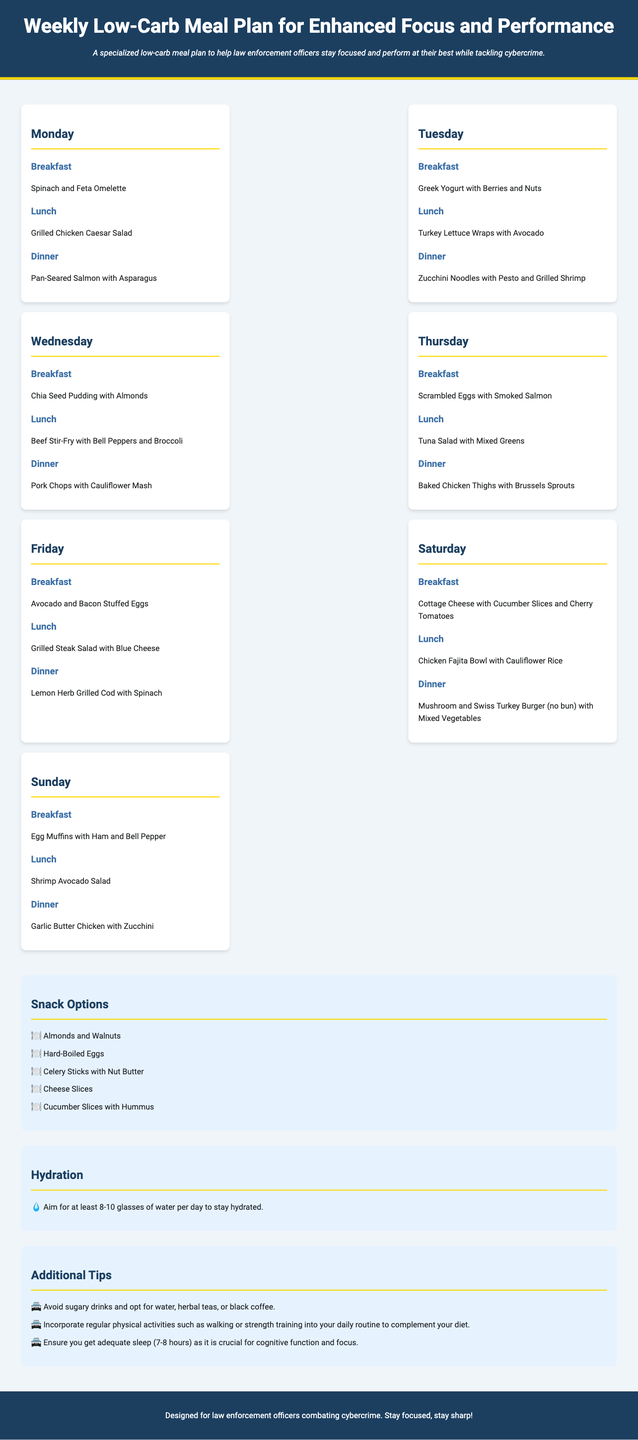What is the title of the meal plan? The title of the meal plan is provided in the header of the document.
Answer: Weekly Low-Carb Meal Plan for Enhanced Focus and Performance How many meals are outlined for each day? Each day contains three meals: breakfast, lunch, and dinner, as detailed in the meal plan section.
Answer: 3 What is the breakfast option for Wednesday? The breakfast option for Wednesday is listed in the meal details for that day.
Answer: Chia Seed Pudding with Almonds Which snack includes nut butter? The options listed in the snack section indicate which ones contain nut butter.
Answer: Celery Sticks with Nut Butter What is recommended for hydration? The hydration section of the document specifies what should be consumed for staying hydrated.
Answer: 8-10 glasses of water What meal accompanies grilled steak? By reviewing the lunch options, it's clear which meal corresponds to grilled steak.
Answer: Grilled Steak Salad with Blue Cheese On which day is the tuna salad mentioned? The day associated with tuna salad can be found in the meal plan day sections.
Answer: Thursday What is one of the additional tips provided? The tips section lists various recommendations for improving health and focus.
Answer: Avoid sugary drinks and opt for water, herbal teas, or black coffee 